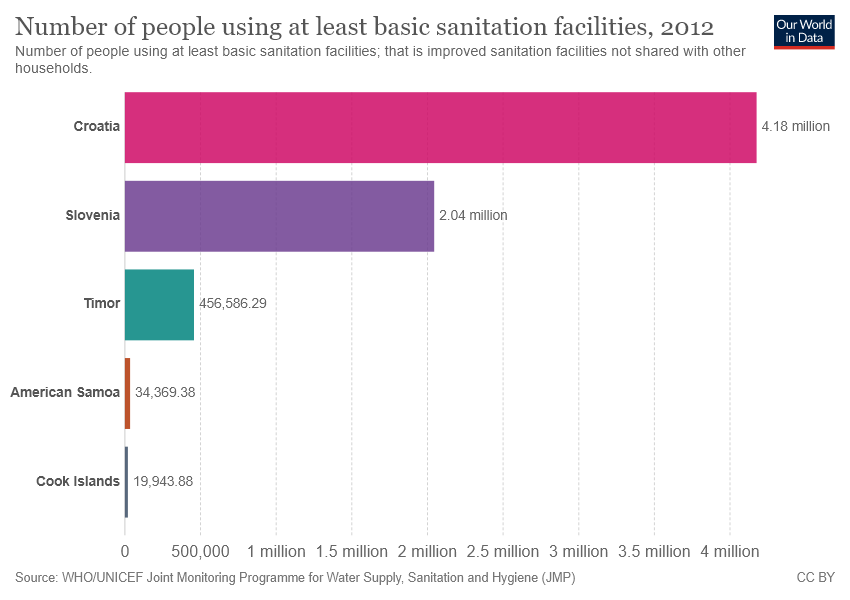Indicate a few pertinent items in this graphic. The value of the largest bar is 4.18... The sum of the two smallest bars is less than the third smallest bar. 